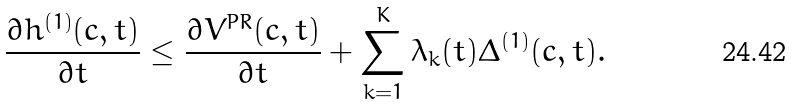<formula> <loc_0><loc_0><loc_500><loc_500>\frac { \partial h ^ { ( 1 ) } ( c , t ) } { \partial t } \leq \frac { \partial V ^ { P R } ( c , t ) } { \partial t } + \sum _ { k = 1 } ^ { K } \lambda _ { k } ( t ) \Delta ^ { ( 1 ) } ( c , t ) .</formula> 